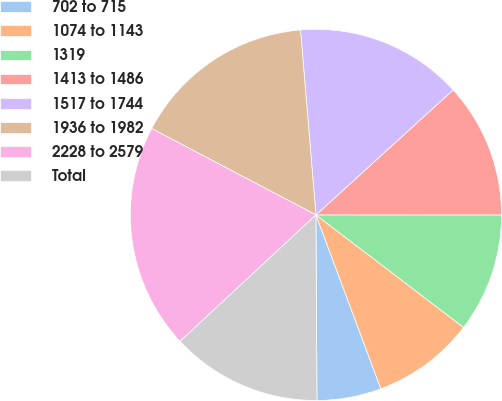<chart> <loc_0><loc_0><loc_500><loc_500><pie_chart><fcel>702 to 715<fcel>1074 to 1143<fcel>1319<fcel>1413 to 1486<fcel>1517 to 1744<fcel>1936 to 1982<fcel>2228 to 2579<fcel>Total<nl><fcel>5.6%<fcel>8.95%<fcel>10.36%<fcel>11.76%<fcel>14.57%<fcel>15.97%<fcel>19.63%<fcel>13.16%<nl></chart> 